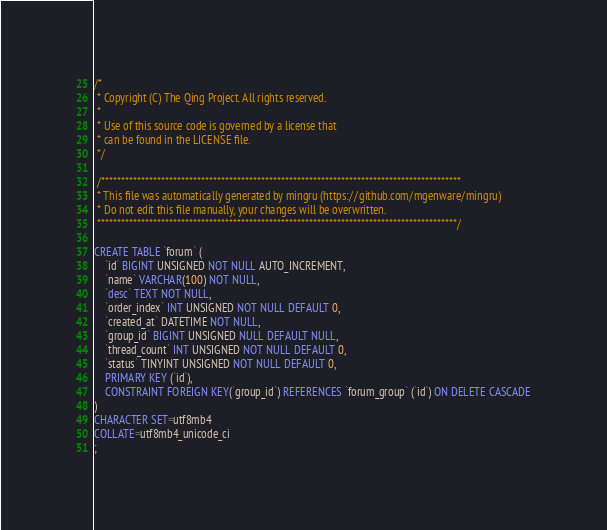<code> <loc_0><loc_0><loc_500><loc_500><_SQL_>/*
 * Copyright (C) The Qing Project. All rights reserved.
 *
 * Use of this source code is governed by a license that
 * can be found in the LICENSE file.
 */

 /******************************************************************************************
 * This file was automatically generated by mingru (https://github.com/mgenware/mingru)
 * Do not edit this file manually, your changes will be overwritten.
 ******************************************************************************************/

CREATE TABLE `forum` (
	`id` BIGINT UNSIGNED NOT NULL AUTO_INCREMENT,
	`name` VARCHAR(100) NOT NULL,
	`desc` TEXT NOT NULL,
	`order_index` INT UNSIGNED NOT NULL DEFAULT 0,
	`created_at` DATETIME NOT NULL,
	`group_id` BIGINT UNSIGNED NULL DEFAULT NULL,
	`thread_count` INT UNSIGNED NOT NULL DEFAULT 0,
	`status` TINYINT UNSIGNED NOT NULL DEFAULT 0,
	PRIMARY KEY (`id`),
	CONSTRAINT FOREIGN KEY(`group_id`) REFERENCES `forum_group` (`id`) ON DELETE CASCADE
)
CHARACTER SET=utf8mb4
COLLATE=utf8mb4_unicode_ci
;
</code> 